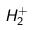<formula> <loc_0><loc_0><loc_500><loc_500>H _ { 2 } ^ { + }</formula> 